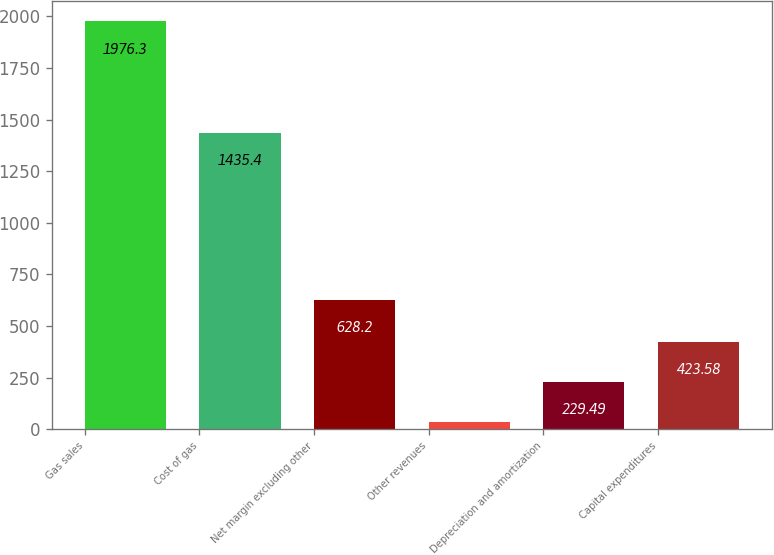Convert chart to OTSL. <chart><loc_0><loc_0><loc_500><loc_500><bar_chart><fcel>Gas sales<fcel>Cost of gas<fcel>Net margin excluding other<fcel>Other revenues<fcel>Depreciation and amortization<fcel>Capital expenditures<nl><fcel>1976.3<fcel>1435.4<fcel>628.2<fcel>35.4<fcel>229.49<fcel>423.58<nl></chart> 